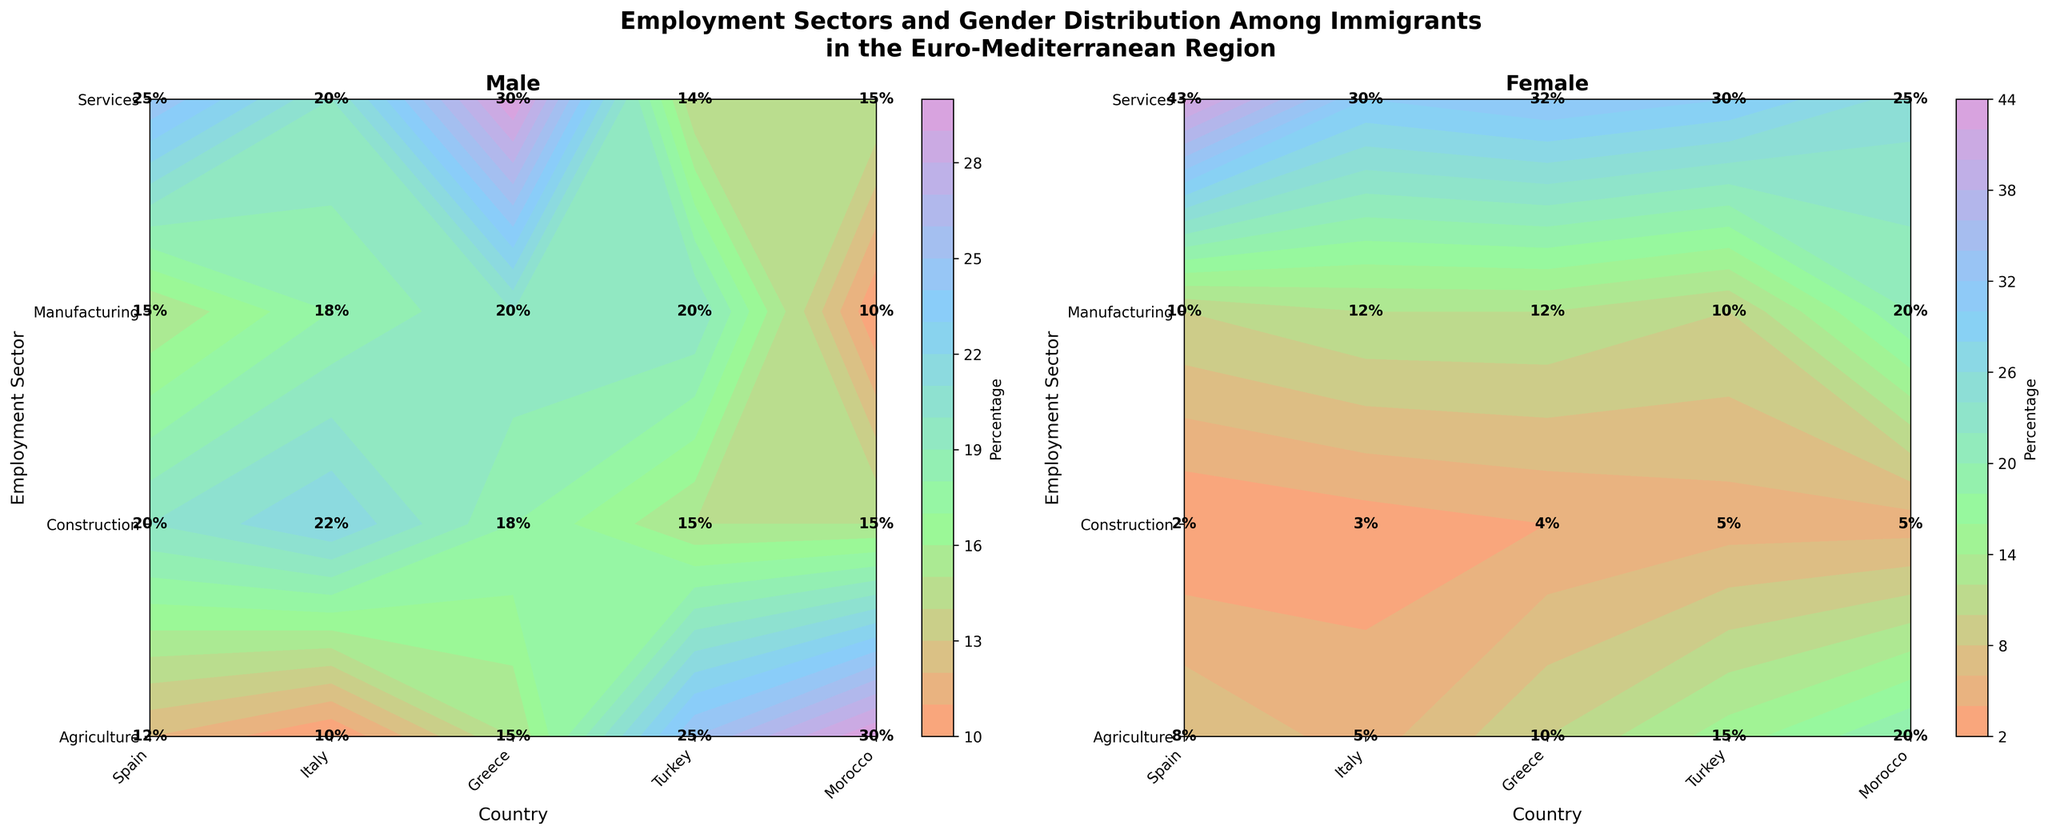What is the title of the figure? At the top of the figure, the title is specified in bold text.
Answer: Employment Sectors and Gender Distribution Among Immigrants in the Euro-Mediterranean Region Which country has the highest percentage of male immigrants working in agriculture? Look at the "Male" contour plot and identify the highest number in the Agriculture row.
Answer: Morocco Among female immigrants, which employment sector has the lowest percentage in Italy? Look at the "Female" contour plot for Italy and identify the smallest percentage.
Answer: Construction What is the percentage difference between male and female immigrants in the services sector in Greece? In the "Male" plot, the percentage for Services in Greece is 30%. In the "Female" plot, it is 32%. Subtract the smaller percentage from the larger one.
Answer: 2% Compare the gender distribution in the manufacturing sector in Turkey. Which gender has a higher percentage, and by how much? In Turkey, the "Male" percentage for Manufacturing is 20%, and the "Female" percentage is 10%. Subtract the smaller value from the larger one to find the difference.
Answer: Male, 10 % Which country shows the smallest gender disparity in the agricultural sector and what is the percentage difference? Compare the differences between the male and female percentages in the Agriculture row across all countries.
Answer: Italy, 5% In the services sector, which country has the highest percentage for female immigrants? Identify the highest figure in the Services row in the "Female" contour plot.
Answer: Spain How does the percentage of male immigrants in the manufacturing sector in Spain compare to that in Greece? In the "Male" plot, the percentage for Manufacturing in Spain is 15%. In Greece, it’s 20%. Compare these values.
Answer: Greece has a higher percentage by 5% What is the average percentage of female immigrants working in agriculture across all countries? Sum the percentages for female immigrants in Agriculture across all countries (Spain: 8%, Italy: 5%, Greece: 10%, Turkey: 15%, Morocco: 20%) and divide by the number of countries.
Answer: 11.6% Which employment sector in Morocco shows a higher female presence compared to male? Compare percentages in all sectors in the "Female" and "Male" plots for Morocco to identify which sector has higher values for females.
Answer: Manufacturing 